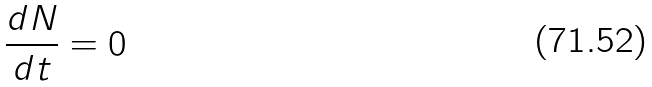<formula> <loc_0><loc_0><loc_500><loc_500>\frac { d N } { d t } = 0</formula> 